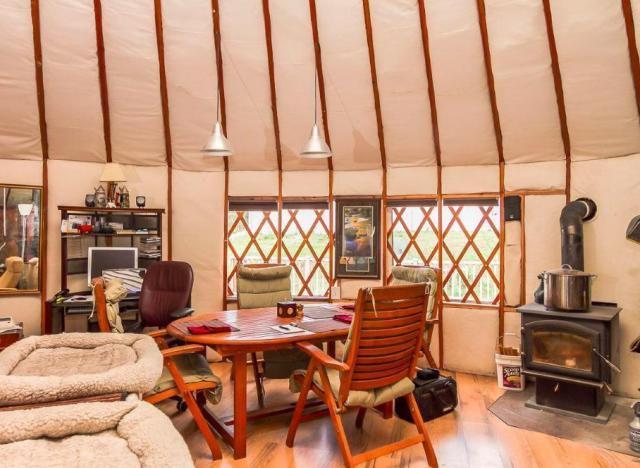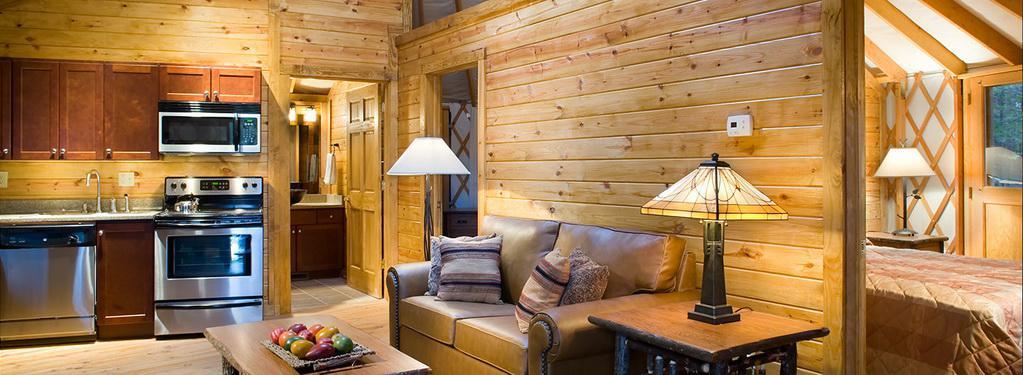The first image is the image on the left, the second image is the image on the right. Considering the images on both sides, is "At least one table is at the foot of the bed." valid? Answer yes or no. No. The first image is the image on the left, the second image is the image on the right. Considering the images on both sides, is "Both images are inside a yurt and the table in one of them is on top of a rug." valid? Answer yes or no. No. 